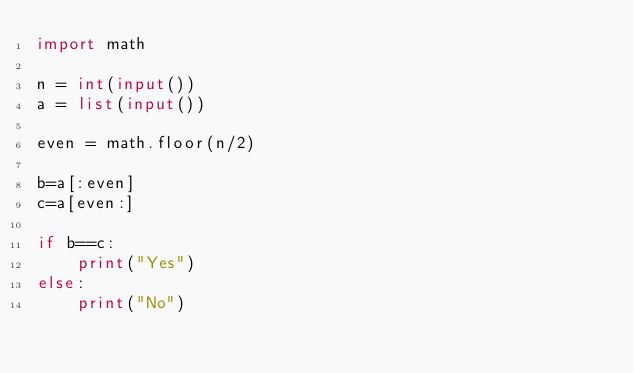Convert code to text. <code><loc_0><loc_0><loc_500><loc_500><_Python_>import math

n = int(input())
a = list(input())

even = math.floor(n/2)

b=a[:even]
c=a[even:]

if b==c:
    print("Yes")
else:
    print("No")</code> 